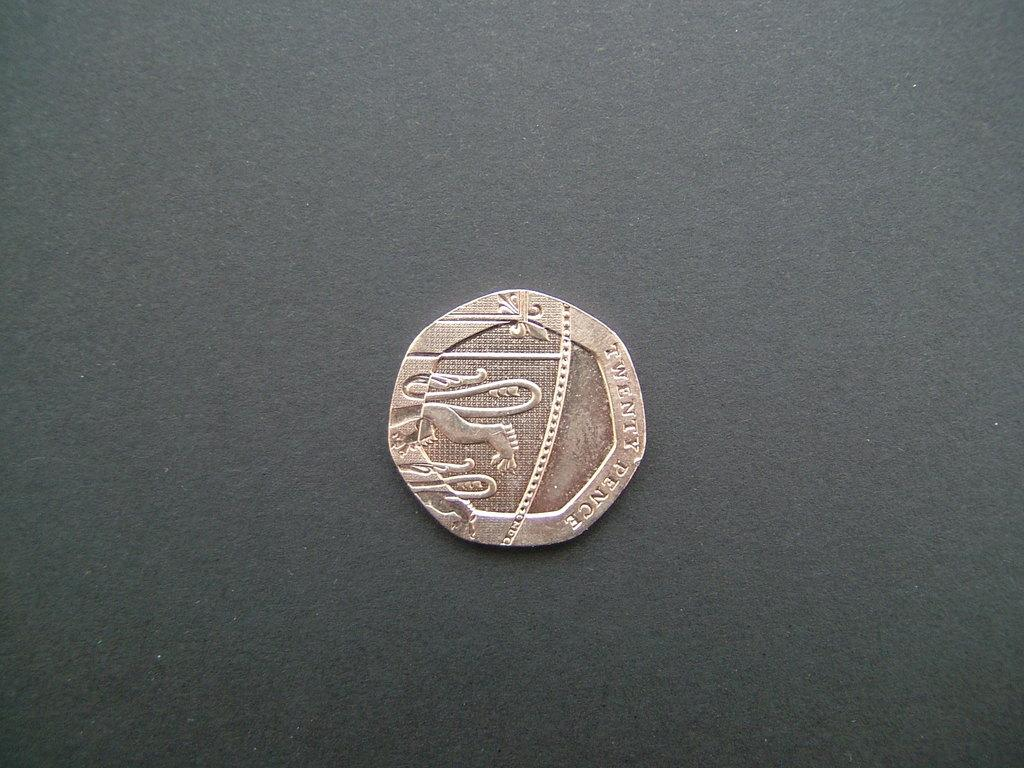<image>
Present a compact description of the photo's key features. the word twenty is on a little coin 